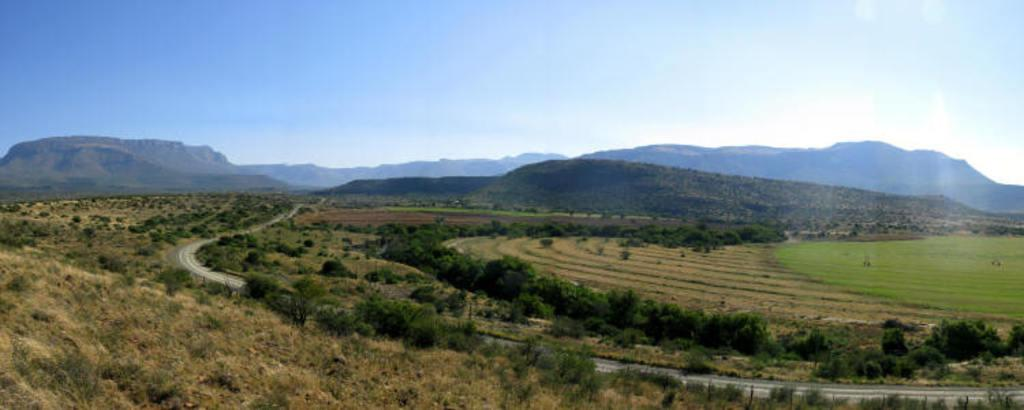What type of vegetation can be seen in the image? There are trees in the image. What type of man-made structure is present in the image? There is a road in the image. What can be seen in the distance in the image? Hills are visible in the background of the image. What is visible above the trees and hills in the image? The sky is visible in the background of the image. Can you see a robin swimming in the image? There is no robin or swimming activity present in the image. Is there a bike parked on the side of the road in the image? There is no bike visible in the image. 